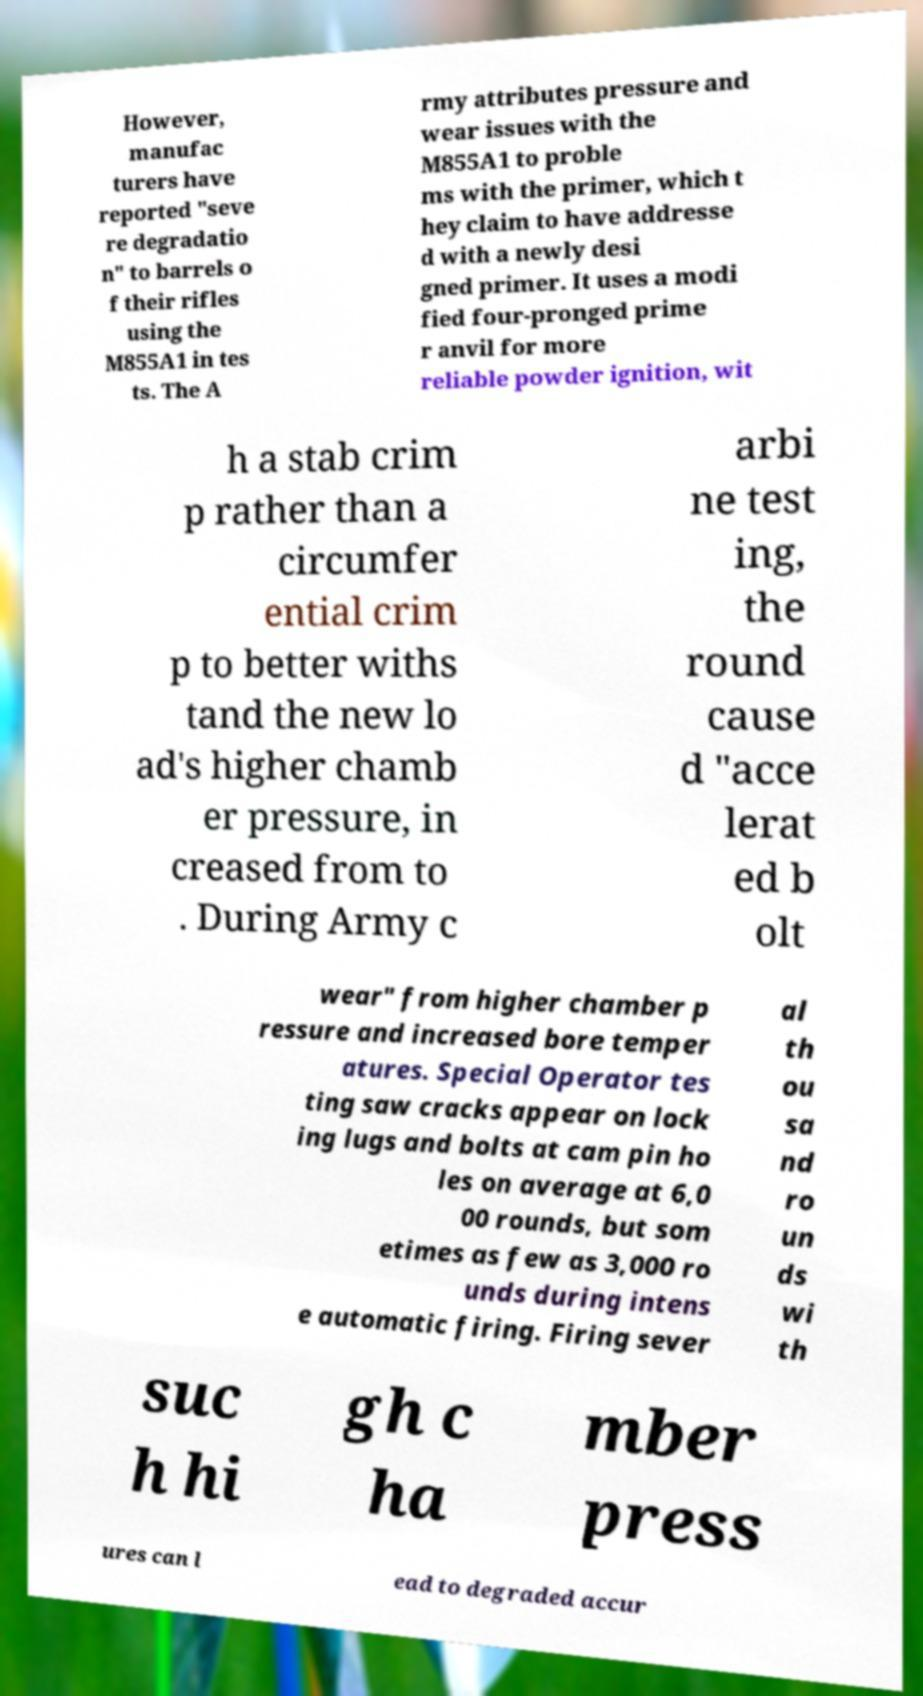Please identify and transcribe the text found in this image. However, manufac turers have reported "seve re degradatio n" to barrels o f their rifles using the M855A1 in tes ts. The A rmy attributes pressure and wear issues with the M855A1 to proble ms with the primer, which t hey claim to have addresse d with a newly desi gned primer. It uses a modi fied four-pronged prime r anvil for more reliable powder ignition, wit h a stab crim p rather than a circumfer ential crim p to better withs tand the new lo ad's higher chamb er pressure, in creased from to . During Army c arbi ne test ing, the round cause d "acce lerat ed b olt wear" from higher chamber p ressure and increased bore temper atures. Special Operator tes ting saw cracks appear on lock ing lugs and bolts at cam pin ho les on average at 6,0 00 rounds, but som etimes as few as 3,000 ro unds during intens e automatic firing. Firing sever al th ou sa nd ro un ds wi th suc h hi gh c ha mber press ures can l ead to degraded accur 